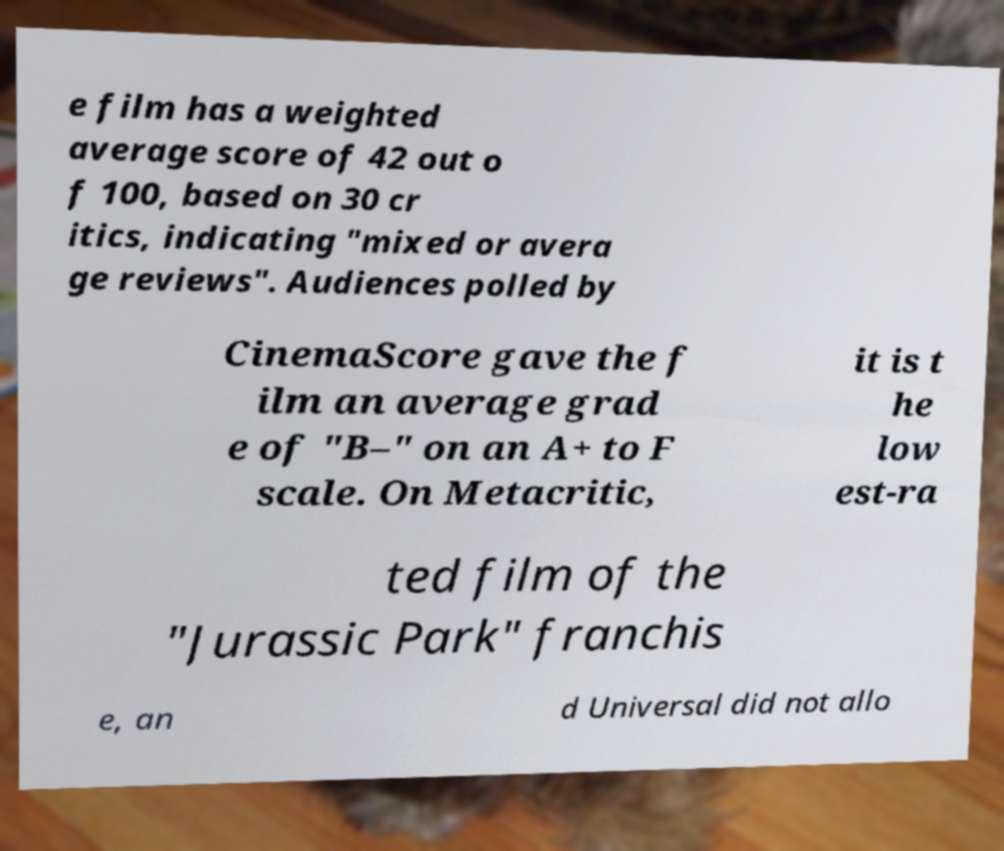Can you accurately transcribe the text from the provided image for me? e film has a weighted average score of 42 out o f 100, based on 30 cr itics, indicating "mixed or avera ge reviews". Audiences polled by CinemaScore gave the f ilm an average grad e of "B–" on an A+ to F scale. On Metacritic, it is t he low est-ra ted film of the "Jurassic Park" franchis e, an d Universal did not allo 